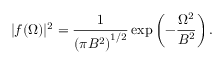Convert formula to latex. <formula><loc_0><loc_0><loc_500><loc_500>| f ( \Omega ) | ^ { 2 } = \frac { 1 } { \left ( \pi B ^ { 2 } \right ) ^ { 1 / 2 } } \exp \left ( - \frac { \Omega ^ { 2 } } { B ^ { 2 } } \right ) .</formula> 